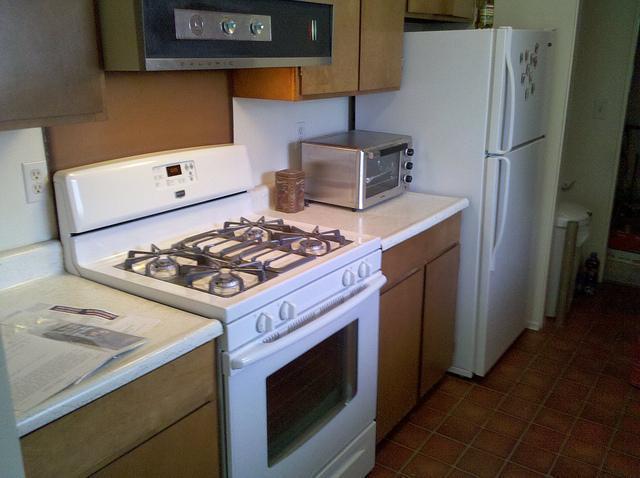How many ovens can you see?
Give a very brief answer. 2. 